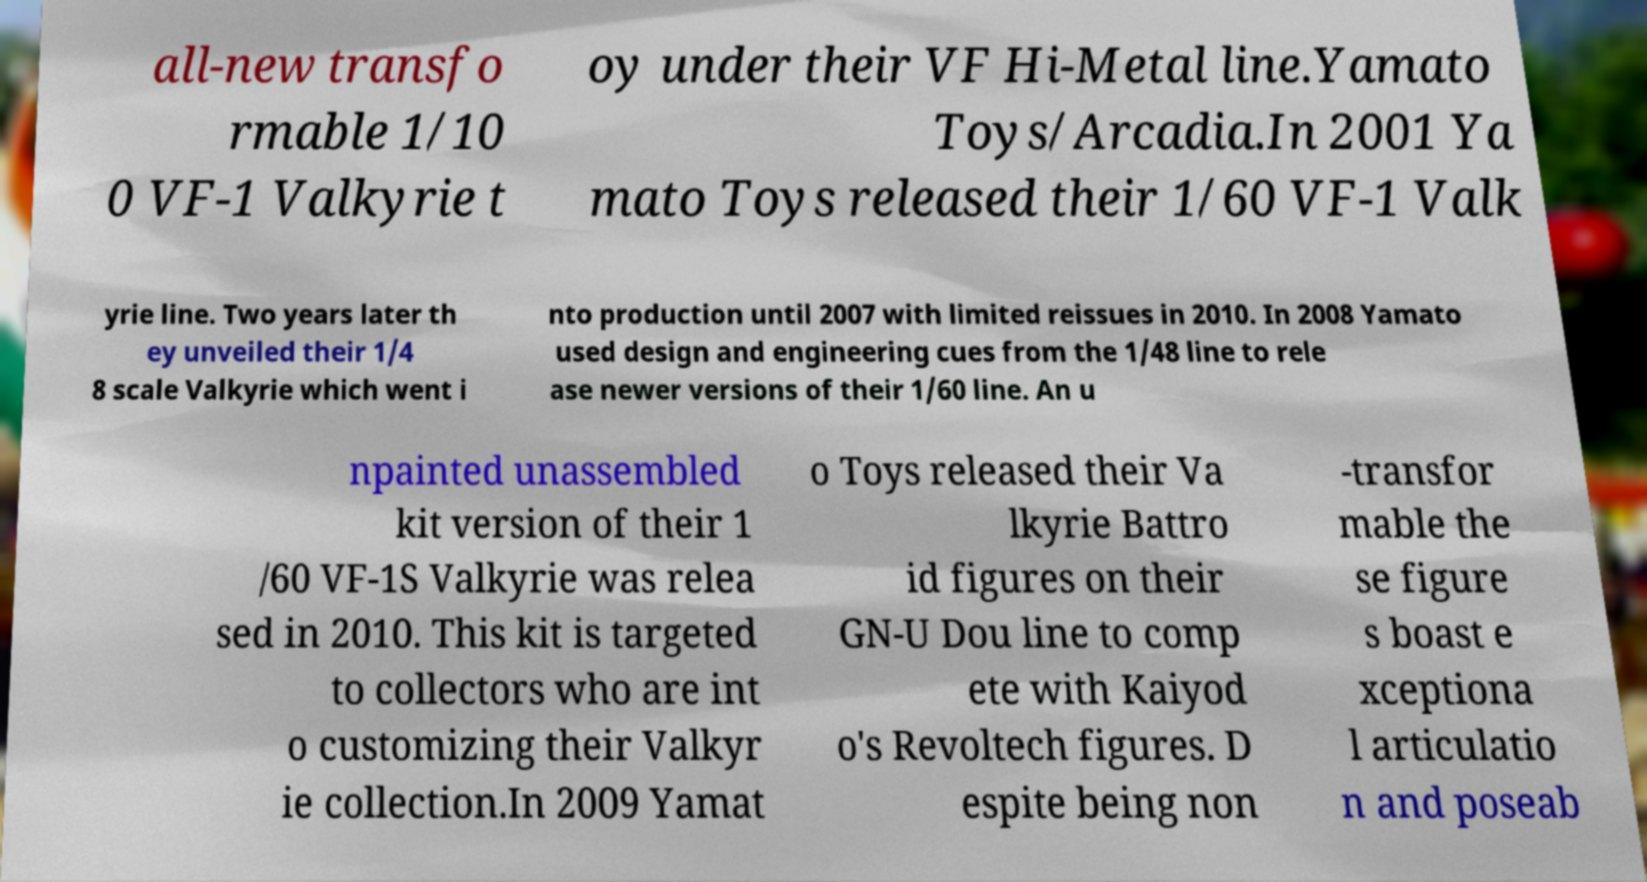I need the written content from this picture converted into text. Can you do that? all-new transfo rmable 1/10 0 VF-1 Valkyrie t oy under their VF Hi-Metal line.Yamato Toys/Arcadia.In 2001 Ya mato Toys released their 1/60 VF-1 Valk yrie line. Two years later th ey unveiled their 1/4 8 scale Valkyrie which went i nto production until 2007 with limited reissues in 2010. In 2008 Yamato used design and engineering cues from the 1/48 line to rele ase newer versions of their 1/60 line. An u npainted unassembled kit version of their 1 /60 VF-1S Valkyrie was relea sed in 2010. This kit is targeted to collectors who are int o customizing their Valkyr ie collection.In 2009 Yamat o Toys released their Va lkyrie Battro id figures on their GN-U Dou line to comp ete with Kaiyod o's Revoltech figures. D espite being non -transfor mable the se figure s boast e xceptiona l articulatio n and poseab 